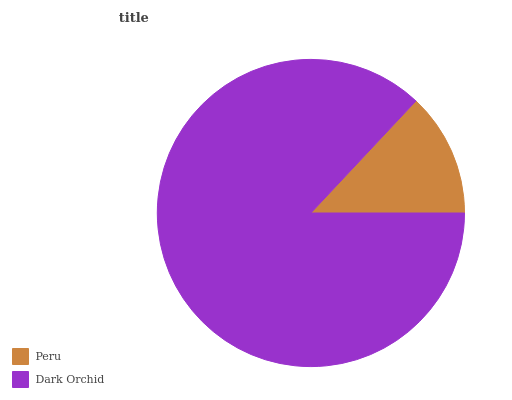Is Peru the minimum?
Answer yes or no. Yes. Is Dark Orchid the maximum?
Answer yes or no. Yes. Is Dark Orchid the minimum?
Answer yes or no. No. Is Dark Orchid greater than Peru?
Answer yes or no. Yes. Is Peru less than Dark Orchid?
Answer yes or no. Yes. Is Peru greater than Dark Orchid?
Answer yes or no. No. Is Dark Orchid less than Peru?
Answer yes or no. No. Is Dark Orchid the high median?
Answer yes or no. Yes. Is Peru the low median?
Answer yes or no. Yes. Is Peru the high median?
Answer yes or no. No. Is Dark Orchid the low median?
Answer yes or no. No. 